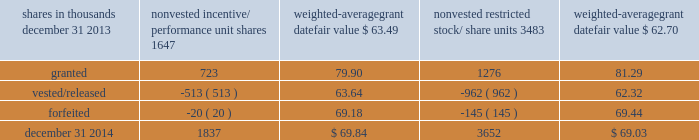To determine stock-based compensation expense , the grant date fair value is applied to the options granted with a reduction for estimated forfeitures .
We recognize compensation expense for stock options on a straight-line basis over the specified vesting period .
At december 31 , 2013 and 2012 , options for 10204000 and 12759000 shares of common stock were exercisable at a weighted-average price of $ 89.46 and $ 90.86 , respectively .
The total intrinsic value of options exercised during 2014 , 2013 and 2012 was $ 90 million , $ 86 million and $ 37 million , respectively .
Cash received from option exercises under all incentive plans for 2014 , 2013 and 2012 was approximately $ 215 million , $ 208 million and $ 118 million , respectively .
The tax benefit realized from option exercises under all incentive plans for 2014 , 2013 and 2012 was approximately $ 33 million , $ 31 million and $ 14 million , respectively .
Shares of common stock available during the next year for the granting of options and other awards under the incentive plans were 17997353 at december 31 , 2014 .
Total shares of pnc common stock authorized for future issuance under equity compensation plans totaled 19017057 shares at december 31 , 2014 , which includes shares available for issuance under the incentive plans and the employee stock purchase plan ( espp ) as described below .
During 2014 , we issued approximately 2.4 million shares from treasury stock in connection with stock option exercise activity .
As with past exercise activity , we currently intend to utilize primarily treasury stock for any future stock option exercises .
Awards granted to non-employee directors in 2014 , 2013 and 2012 include 21490 , 27076 and 25620 deferred stock units , respectively , awarded under the outside directors deferred stock unit plan .
A deferred stock unit is a phantom share of our common stock , which is accounted for as a liability until such awards are paid to the participants in cash .
As there are no vesting or service requirements on these awards , total compensation expense is recognized in full for these awards on the date of grant .
Incentive/performance unit share awards and restricted stock/share unit awards the fair value of nonvested incentive/performance unit share awards and restricted stock/share unit awards is initially determined based on prices not less than the market value of our common stock on the date of grant .
The value of certain incentive/performance unit share awards is subsequently remeasured based on the achievement of one or more financial and other performance goals .
The personnel and compensation committee ( 201cp&cc 201d ) of the board of directors approves the final award payout with respect to certain incentive/performance unit share awards .
These awards have either a three-year or a four-year performance period and are payable in either stock or a combination of stock and cash .
Restricted stock/share unit awards have various vesting periods generally ranging from 3 years to 5 years .
Beginning in 2013 , we incorporated several enhanced risk- related performance changes to certain long-term incentive compensation programs .
In addition to achieving certain financial performance metrics on both an absolute basis and relative to our peers , final payout amounts will be subject to reduction if pnc fails to meet certain risk-related performance metrics as specified in the award agreements .
However , the p&cc has the discretion to waive any or all of this reduction under certain circumstances .
The weighted-average grant date fair value of incentive/ performance unit share awards and restricted stock/unit awards granted in 2014 , 2013 and 2012 was $ 80.79 , $ 64.77 and $ 60.68 per share , respectively .
The total fair value of incentive/performance unit share and restricted stock/unit awards vested during 2014 , 2013 and 2012 was approximately $ 119 million , $ 63 million and $ 55 million , respectively .
We recognize compensation expense for such awards ratably over the corresponding vesting and/or performance periods for each type of program .
Table 121 : nonvested incentive/performance unit share awards and restricted stock/share unit awards 2013 rollforward shares in thousands nonvested incentive/ performance unit shares weighted- average grant date fair value nonvested restricted stock/ weighted- average grant date fair value .
The pnc financial services group , inc .
2013 form 10-k 185 .
What was the approximate average , in millions , for the tax benefit realized from option exercises under all incentive plans for 2014 , 2013 and 2012? 
Computations: (((33 + 31) + 14) / 3)
Answer: 26.0. 